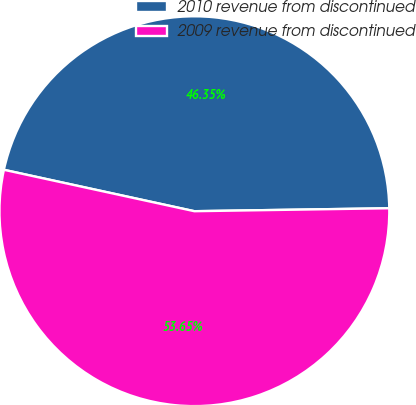<chart> <loc_0><loc_0><loc_500><loc_500><pie_chart><fcel>2010 revenue from discontinued<fcel>2009 revenue from discontinued<nl><fcel>46.35%<fcel>53.65%<nl></chart> 